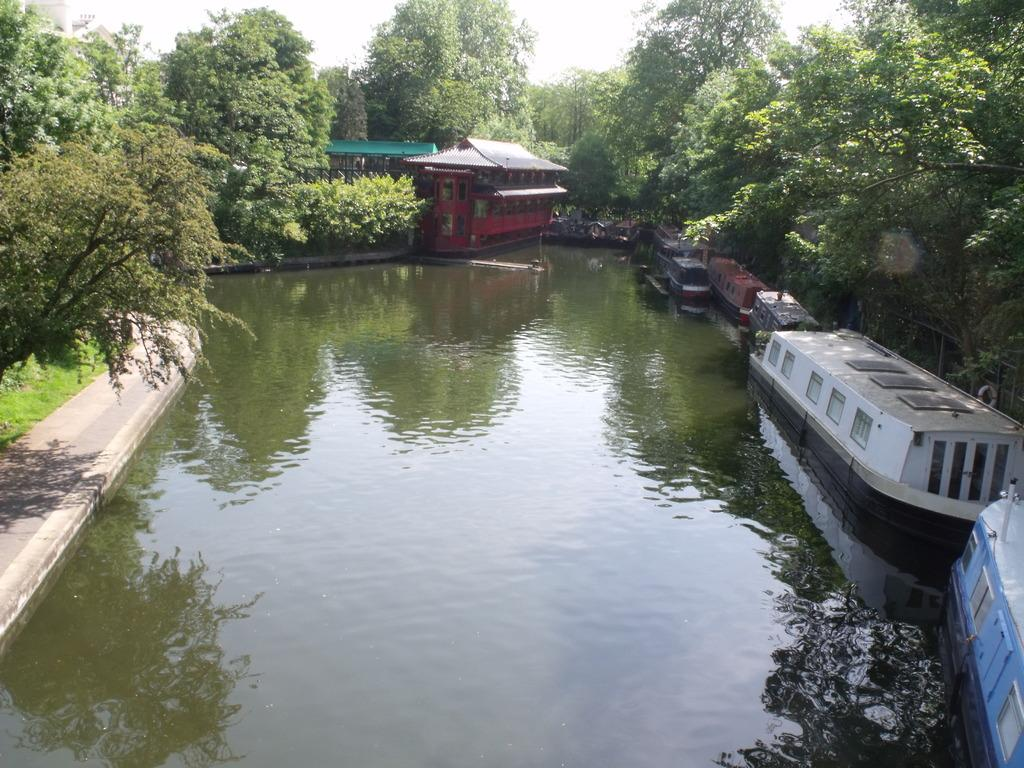What type of structure can be seen in the image? There is a building in the image. What provides shelter or cover in the image? There is a shelter or roof in the image. What type of vehicles are on the water in the image? There are boats on the surface of the water in the image. What is a possible route for walking or traveling in the image? There is a path visible in the image. What type of vegetation is present in the image? Grass is present in the image. What type of tall plants can be seen in the image? Trees are visible in the image. What part of the natural environment is visible in the image? The sky is visible in the image. What type of sea creature can be seen running on the path in the image? There are no sea creatures or running depicted in the image. What type of attraction is present in the image? The image does not show any specific attractions; it features a building, shelter, boats, path, grass, trees, and sky. 